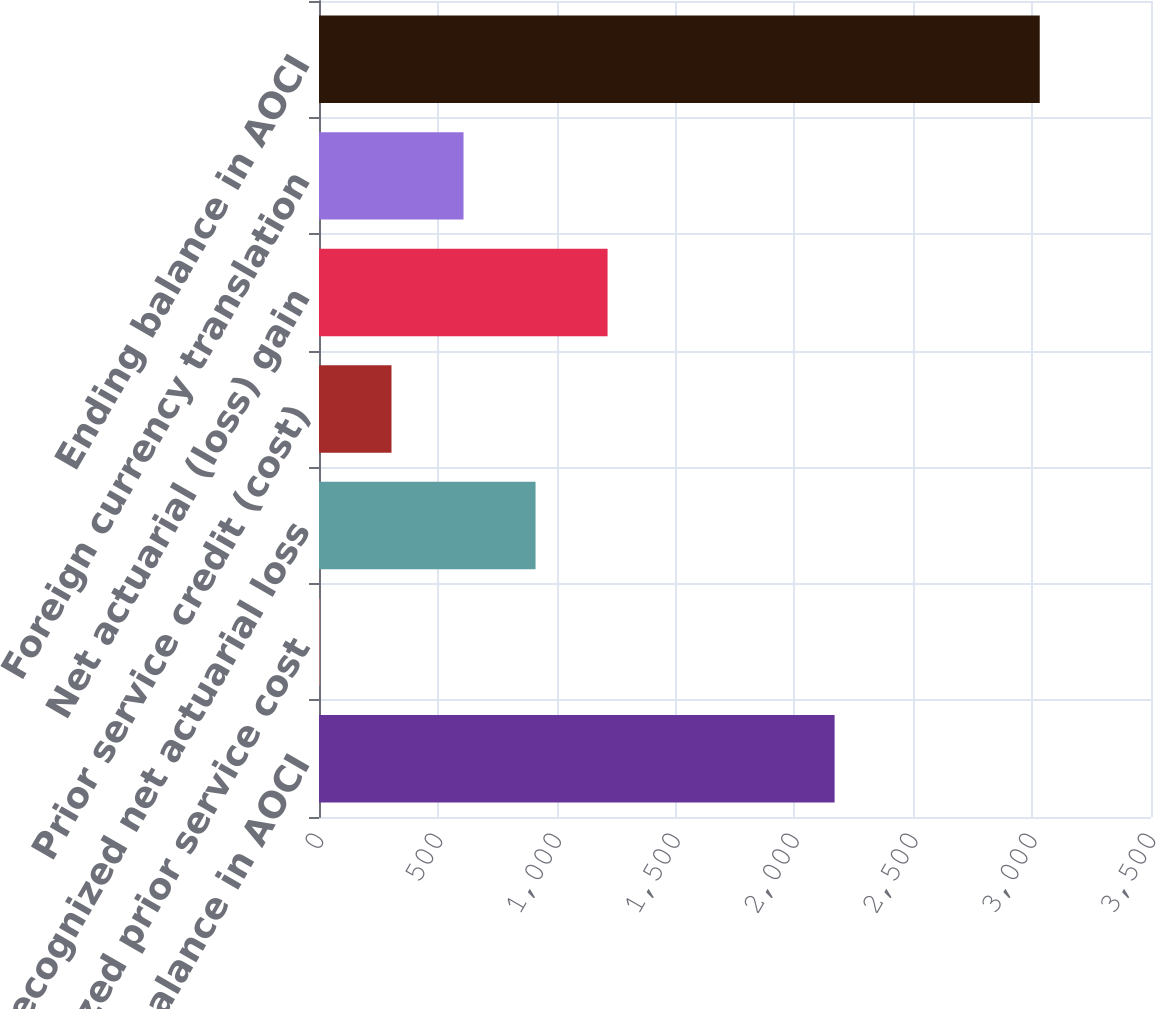Convert chart. <chart><loc_0><loc_0><loc_500><loc_500><bar_chart><fcel>Beginning balance in AOCI<fcel>Recognized prior service cost<fcel>Recognized net actuarial loss<fcel>Prior service credit (cost)<fcel>Net actuarial (loss) gain<fcel>Foreign currency translation<fcel>Ending balance in AOCI<nl><fcel>2169<fcel>2<fcel>911<fcel>305<fcel>1214<fcel>608<fcel>3032<nl></chart> 